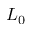Convert formula to latex. <formula><loc_0><loc_0><loc_500><loc_500>L _ { 0 }</formula> 